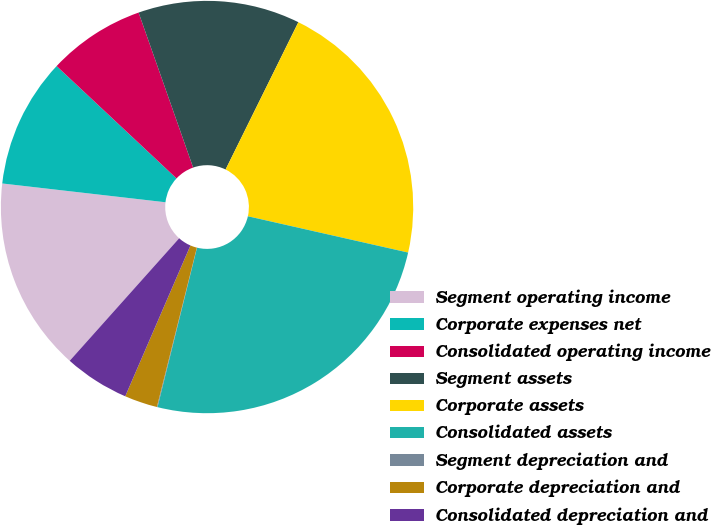Convert chart. <chart><loc_0><loc_0><loc_500><loc_500><pie_chart><fcel>Segment operating income<fcel>Corporate expenses net<fcel>Consolidated operating income<fcel>Segment assets<fcel>Corporate assets<fcel>Consolidated assets<fcel>Segment depreciation and<fcel>Corporate depreciation and<fcel>Consolidated depreciation and<nl><fcel>15.22%<fcel>10.16%<fcel>7.63%<fcel>12.69%<fcel>21.24%<fcel>25.32%<fcel>0.05%<fcel>2.58%<fcel>5.11%<nl></chart> 